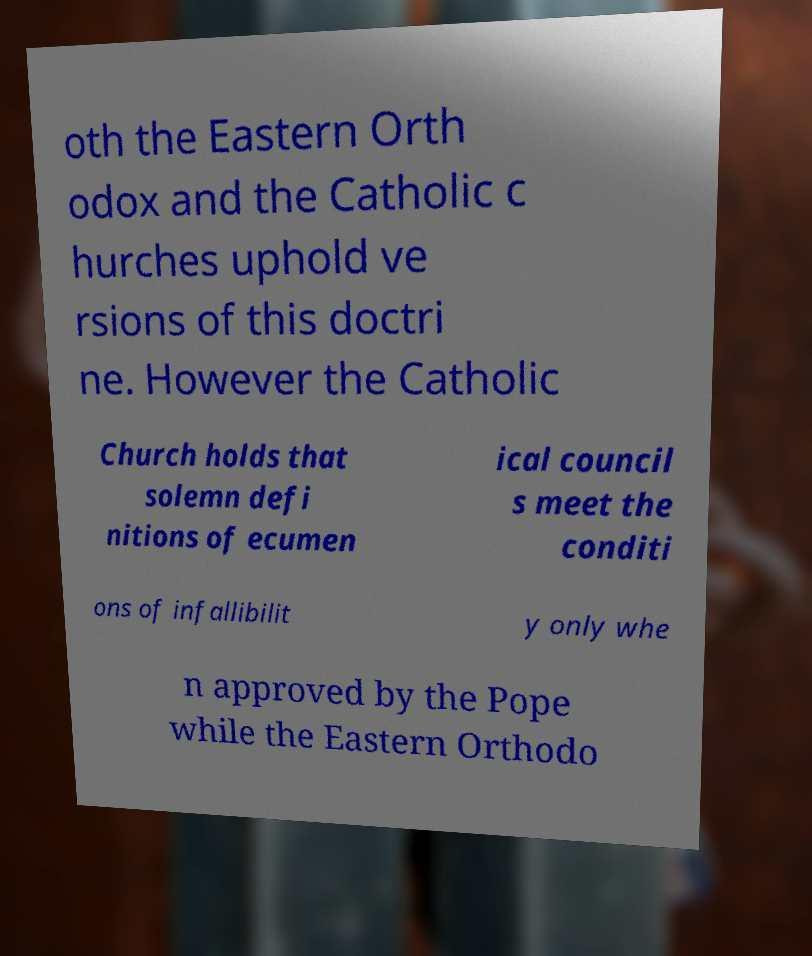Can you accurately transcribe the text from the provided image for me? oth the Eastern Orth odox and the Catholic c hurches uphold ve rsions of this doctri ne. However the Catholic Church holds that solemn defi nitions of ecumen ical council s meet the conditi ons of infallibilit y only whe n approved by the Pope while the Eastern Orthodo 